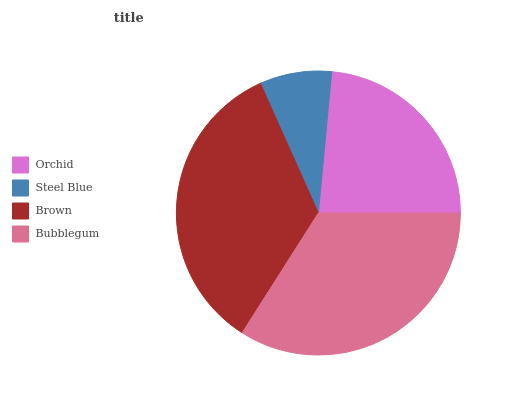Is Steel Blue the minimum?
Answer yes or no. Yes. Is Brown the maximum?
Answer yes or no. Yes. Is Brown the minimum?
Answer yes or no. No. Is Steel Blue the maximum?
Answer yes or no. No. Is Brown greater than Steel Blue?
Answer yes or no. Yes. Is Steel Blue less than Brown?
Answer yes or no. Yes. Is Steel Blue greater than Brown?
Answer yes or no. No. Is Brown less than Steel Blue?
Answer yes or no. No. Is Bubblegum the high median?
Answer yes or no. Yes. Is Orchid the low median?
Answer yes or no. Yes. Is Orchid the high median?
Answer yes or no. No. Is Bubblegum the low median?
Answer yes or no. No. 